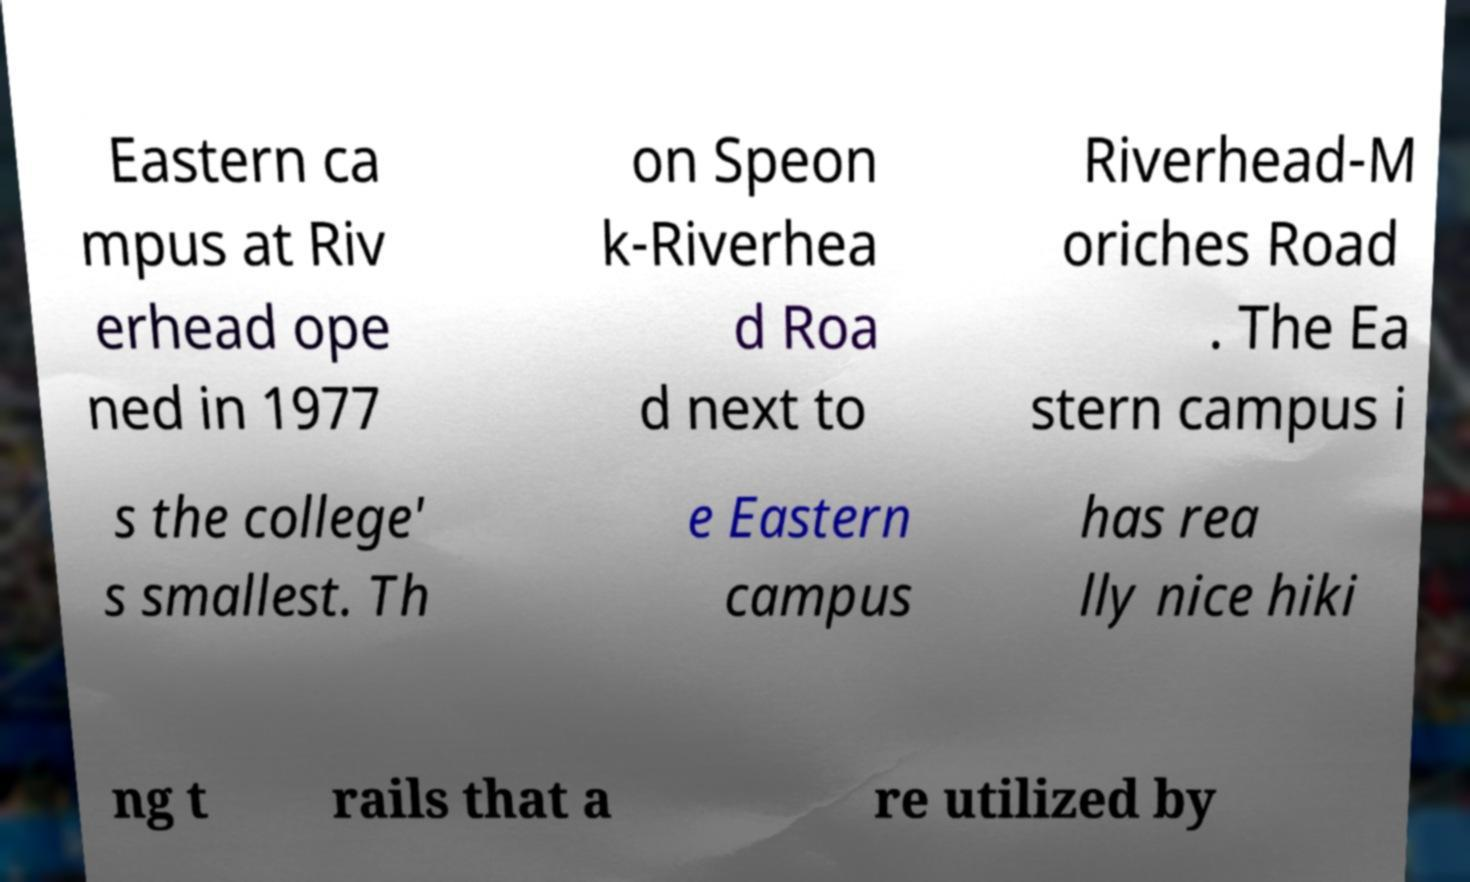For documentation purposes, I need the text within this image transcribed. Could you provide that? Eastern ca mpus at Riv erhead ope ned in 1977 on Speon k-Riverhea d Roa d next to Riverhead-M oriches Road . The Ea stern campus i s the college' s smallest. Th e Eastern campus has rea lly nice hiki ng t rails that a re utilized by 